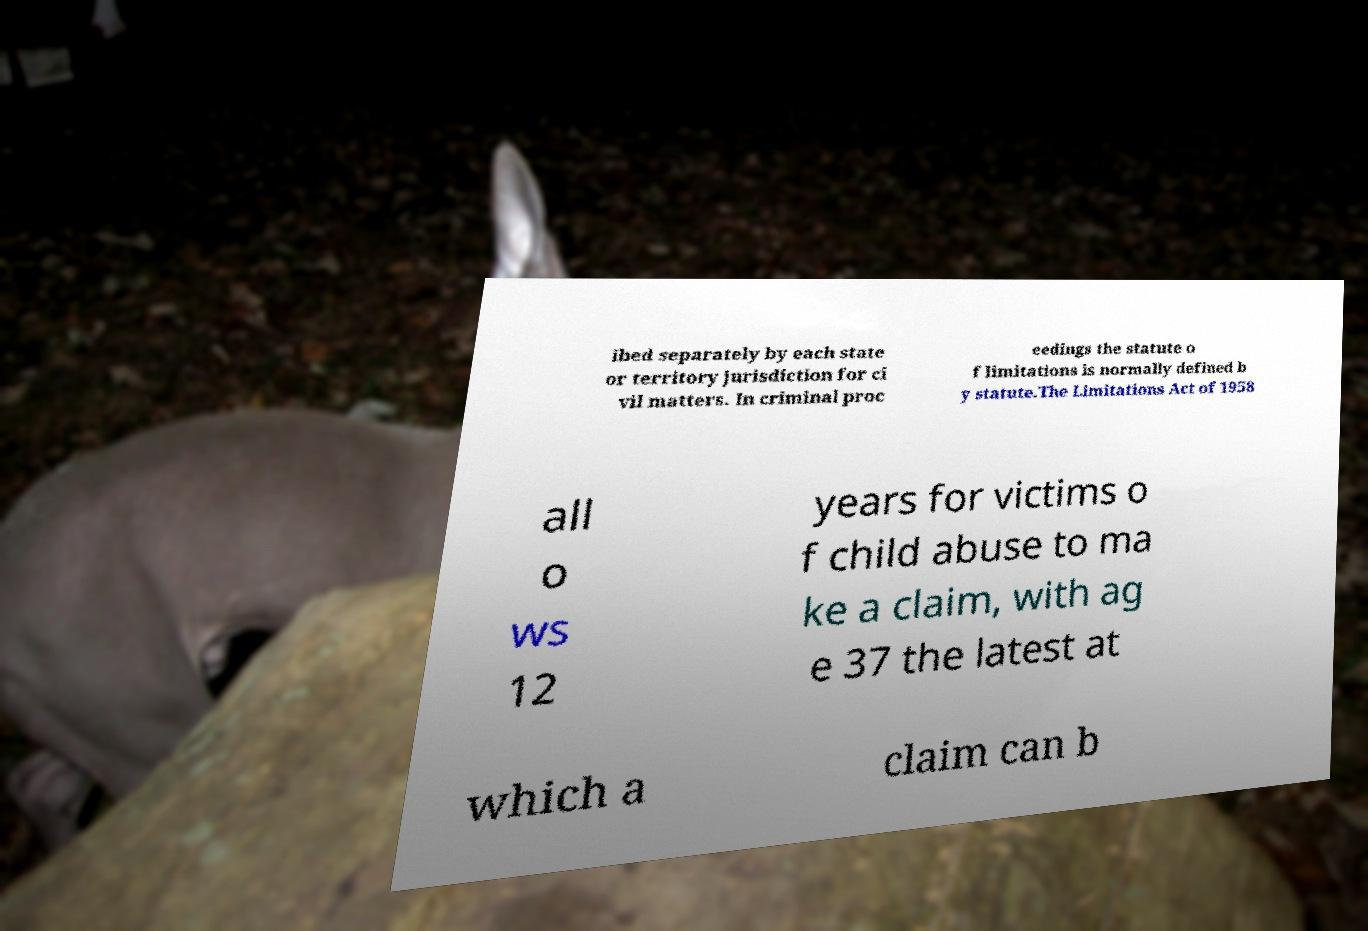For documentation purposes, I need the text within this image transcribed. Could you provide that? ibed separately by each state or territory jurisdiction for ci vil matters. In criminal proc eedings the statute o f limitations is normally defined b y statute.The Limitations Act of 1958 all o ws 12 years for victims o f child abuse to ma ke a claim, with ag e 37 the latest at which a claim can b 